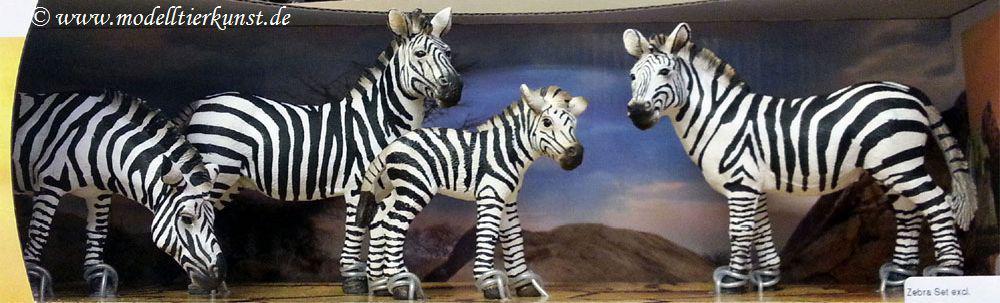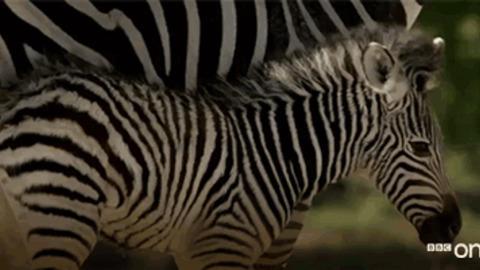The first image is the image on the left, the second image is the image on the right. Analyze the images presented: Is the assertion "In at least one image, zebras are drinking water." valid? Answer yes or no. No. The first image is the image on the left, the second image is the image on the right. For the images displayed, is the sentence "At least five zebras are drinking water." factually correct? Answer yes or no. No. 